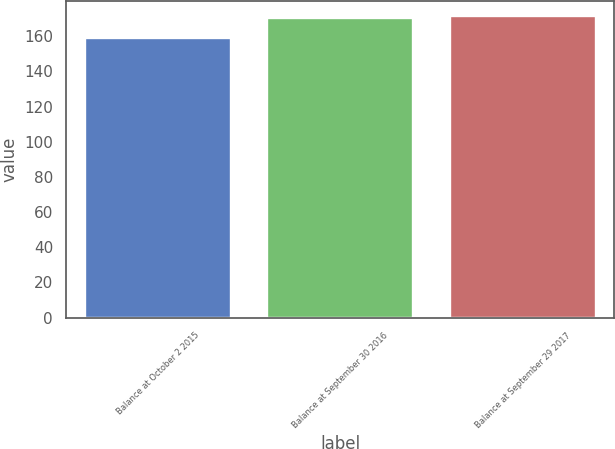<chart> <loc_0><loc_0><loc_500><loc_500><bar_chart><fcel>Balance at October 2 2015<fcel>Balance at September 30 2016<fcel>Balance at September 29 2017<nl><fcel>158.8<fcel>170.2<fcel>171.34<nl></chart> 